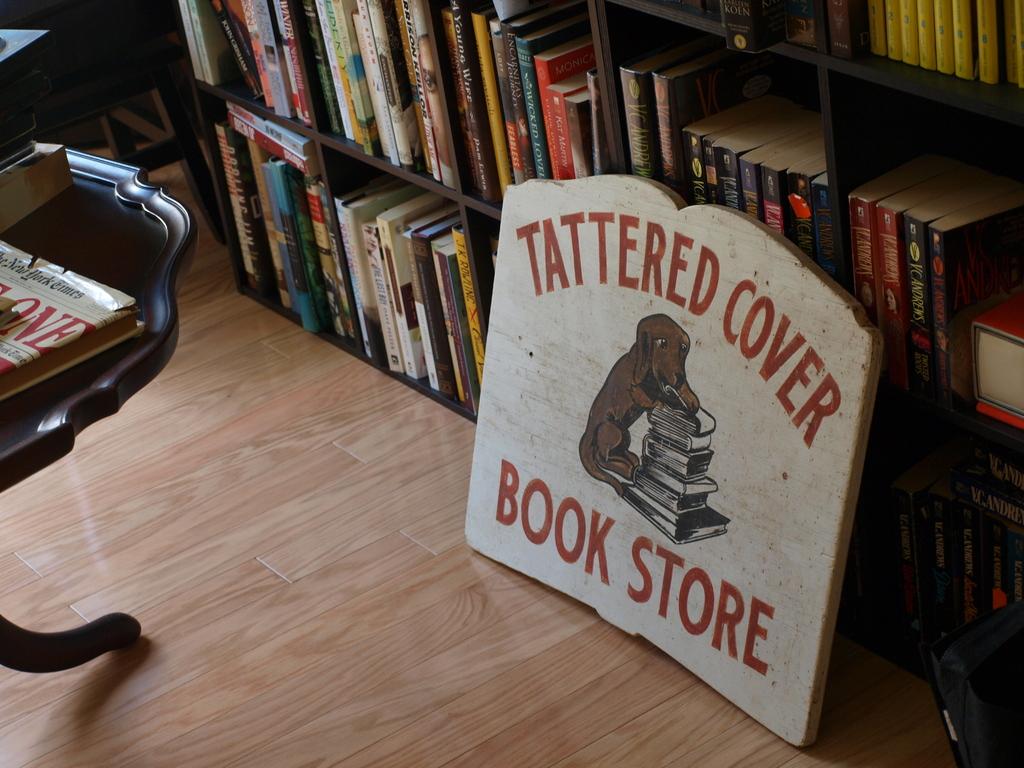What words are at the top of the sign?
Your answer should be very brief. Tattered cover. 